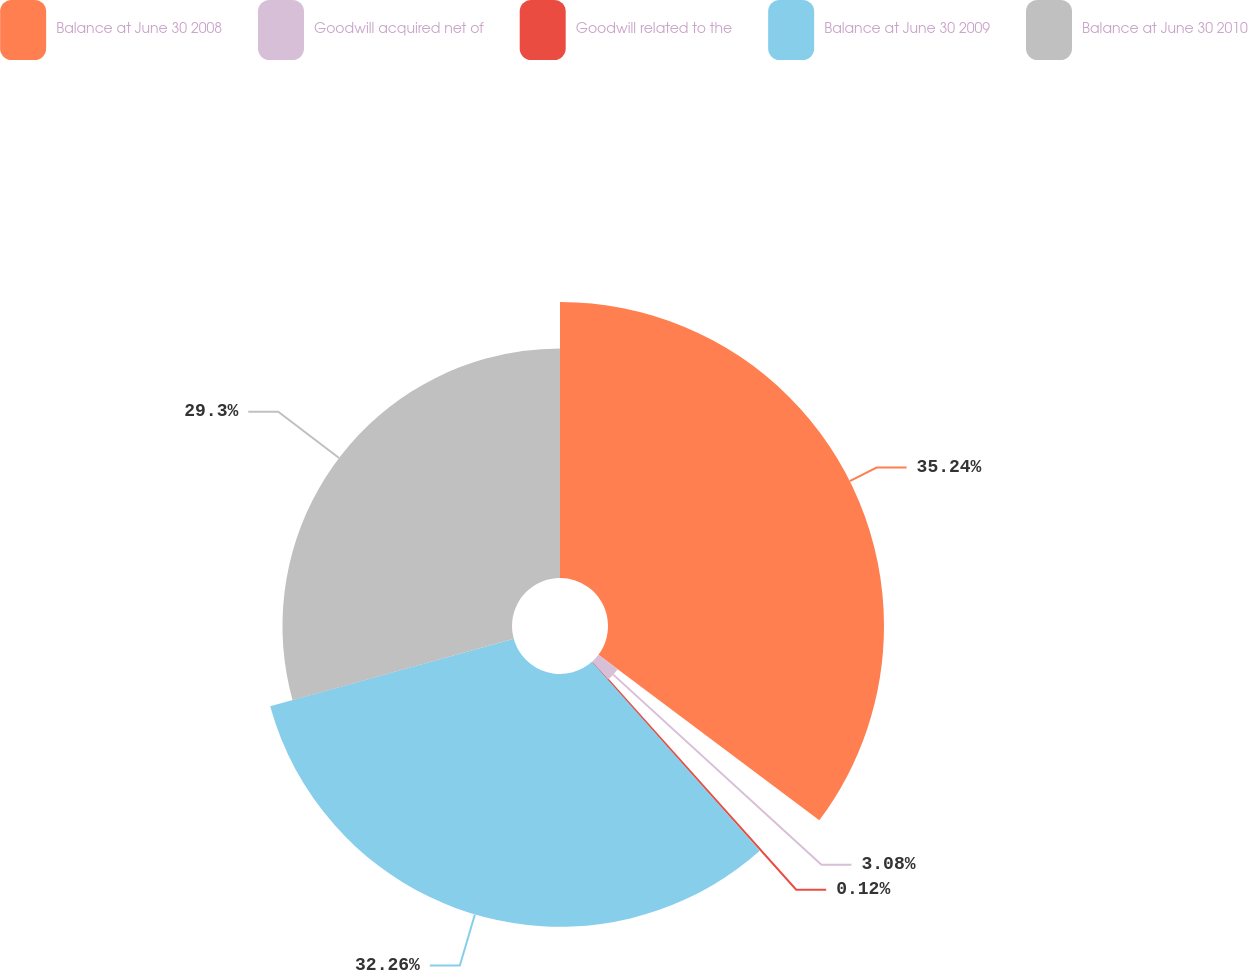Convert chart to OTSL. <chart><loc_0><loc_0><loc_500><loc_500><pie_chart><fcel>Balance at June 30 2008<fcel>Goodwill acquired net of<fcel>Goodwill related to the<fcel>Balance at June 30 2009<fcel>Balance at June 30 2010<nl><fcel>35.23%<fcel>3.08%<fcel>0.12%<fcel>32.26%<fcel>29.3%<nl></chart> 